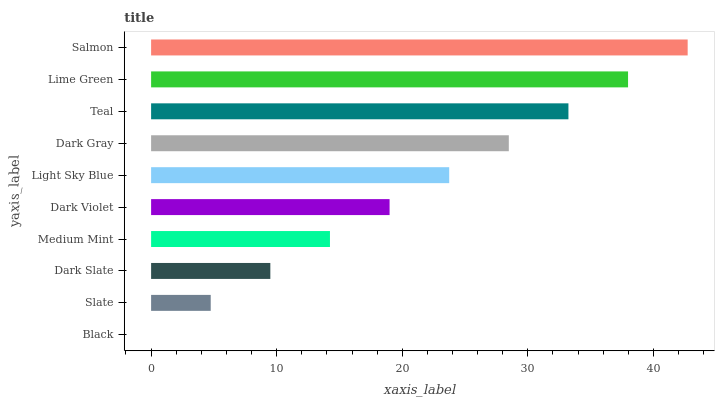Is Black the minimum?
Answer yes or no. Yes. Is Salmon the maximum?
Answer yes or no. Yes. Is Slate the minimum?
Answer yes or no. No. Is Slate the maximum?
Answer yes or no. No. Is Slate greater than Black?
Answer yes or no. Yes. Is Black less than Slate?
Answer yes or no. Yes. Is Black greater than Slate?
Answer yes or no. No. Is Slate less than Black?
Answer yes or no. No. Is Light Sky Blue the high median?
Answer yes or no. Yes. Is Dark Violet the low median?
Answer yes or no. Yes. Is Slate the high median?
Answer yes or no. No. Is Black the low median?
Answer yes or no. No. 